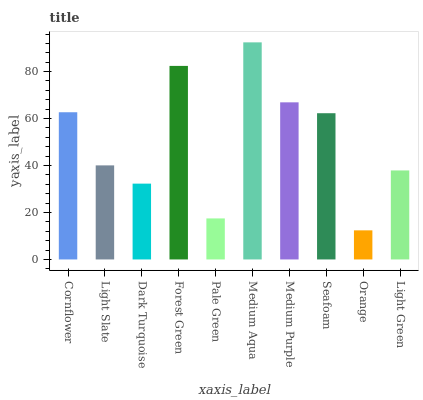Is Orange the minimum?
Answer yes or no. Yes. Is Medium Aqua the maximum?
Answer yes or no. Yes. Is Light Slate the minimum?
Answer yes or no. No. Is Light Slate the maximum?
Answer yes or no. No. Is Cornflower greater than Light Slate?
Answer yes or no. Yes. Is Light Slate less than Cornflower?
Answer yes or no. Yes. Is Light Slate greater than Cornflower?
Answer yes or no. No. Is Cornflower less than Light Slate?
Answer yes or no. No. Is Seafoam the high median?
Answer yes or no. Yes. Is Light Slate the low median?
Answer yes or no. Yes. Is Orange the high median?
Answer yes or no. No. Is Forest Green the low median?
Answer yes or no. No. 